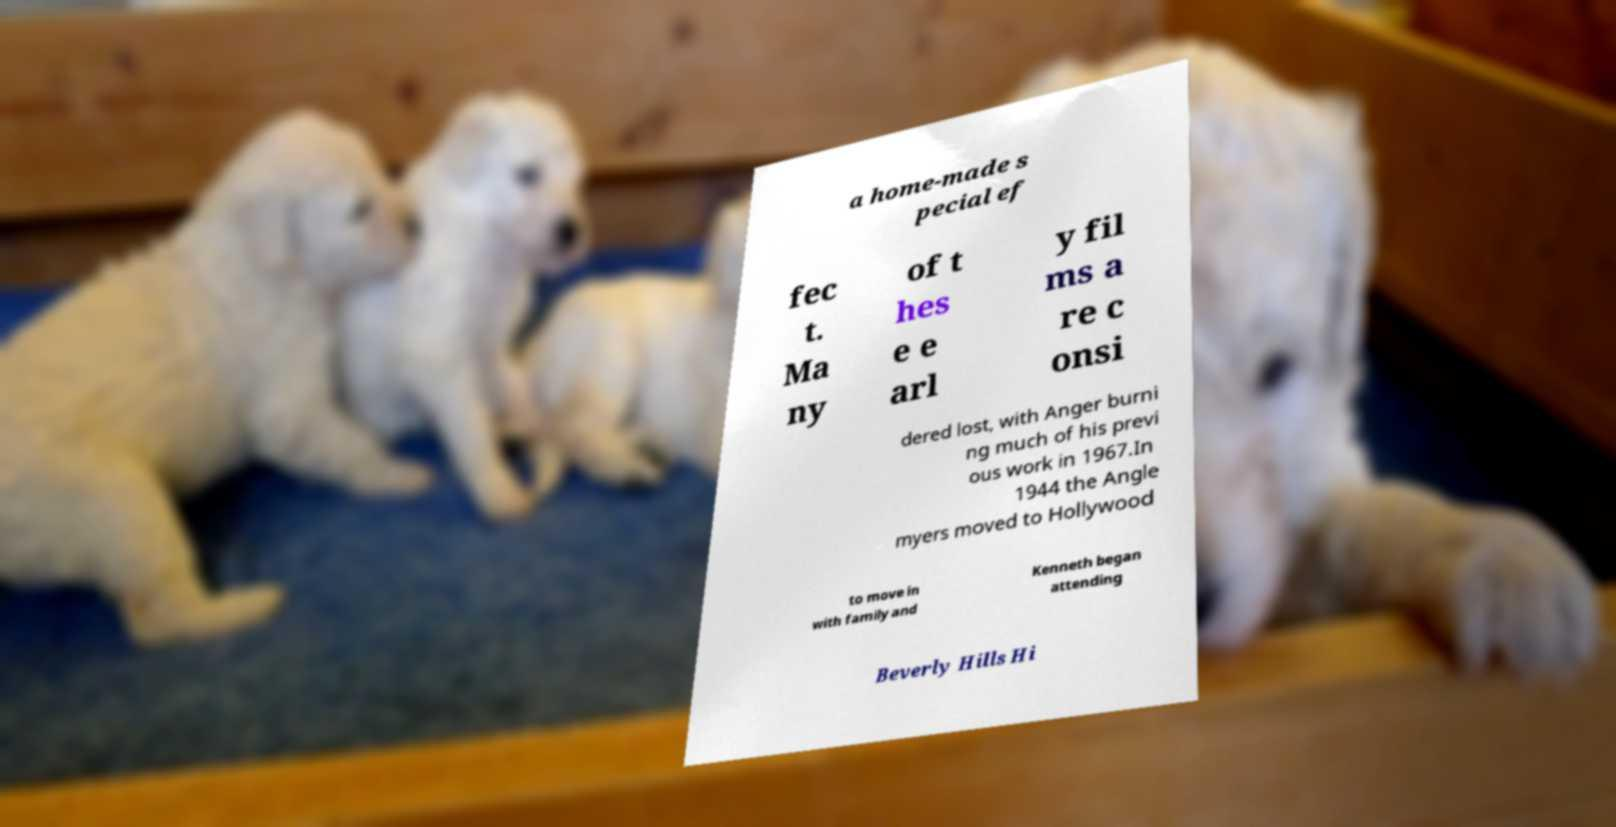Please read and relay the text visible in this image. What does it say? a home-made s pecial ef fec t. Ma ny of t hes e e arl y fil ms a re c onsi dered lost, with Anger burni ng much of his previ ous work in 1967.In 1944 the Angle myers moved to Hollywood to move in with family and Kenneth began attending Beverly Hills Hi 